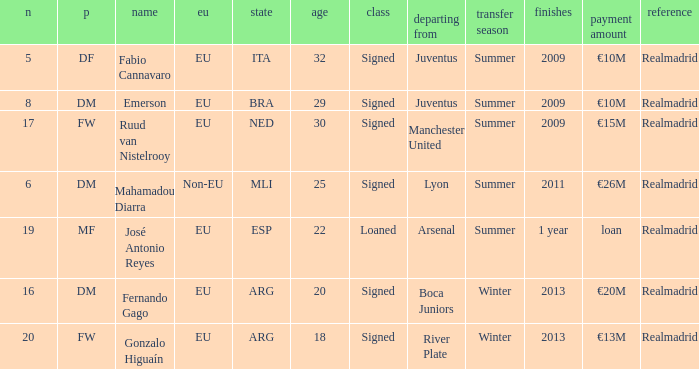What is the type of the player whose transfer fee was €20m? Signed. Help me parse the entirety of this table. {'header': ['n', 'p', 'name', 'eu', 'state', 'age', 'class', 'departing from', 'transfer season', 'finishes', 'payment amount', 'reference'], 'rows': [['5', 'DF', 'Fabio Cannavaro', 'EU', 'ITA', '32', 'Signed', 'Juventus', 'Summer', '2009', '€10M', 'Realmadrid'], ['8', 'DM', 'Emerson', 'EU', 'BRA', '29', 'Signed', 'Juventus', 'Summer', '2009', '€10M', 'Realmadrid'], ['17', 'FW', 'Ruud van Nistelrooy', 'EU', 'NED', '30', 'Signed', 'Manchester United', 'Summer', '2009', '€15M', 'Realmadrid'], ['6', 'DM', 'Mahamadou Diarra', 'Non-EU', 'MLI', '25', 'Signed', 'Lyon', 'Summer', '2011', '€26M', 'Realmadrid'], ['19', 'MF', 'José Antonio Reyes', 'EU', 'ESP', '22', 'Loaned', 'Arsenal', 'Summer', '1 year', 'loan', 'Realmadrid'], ['16', 'DM', 'Fernando Gago', 'EU', 'ARG', '20', 'Signed', 'Boca Juniors', 'Winter', '2013', '€20M', 'Realmadrid'], ['20', 'FW', 'Gonzalo Higuaín', 'EU', 'ARG', '18', 'Signed', 'River Plate', 'Winter', '2013', '€13M', 'Realmadrid']]} 